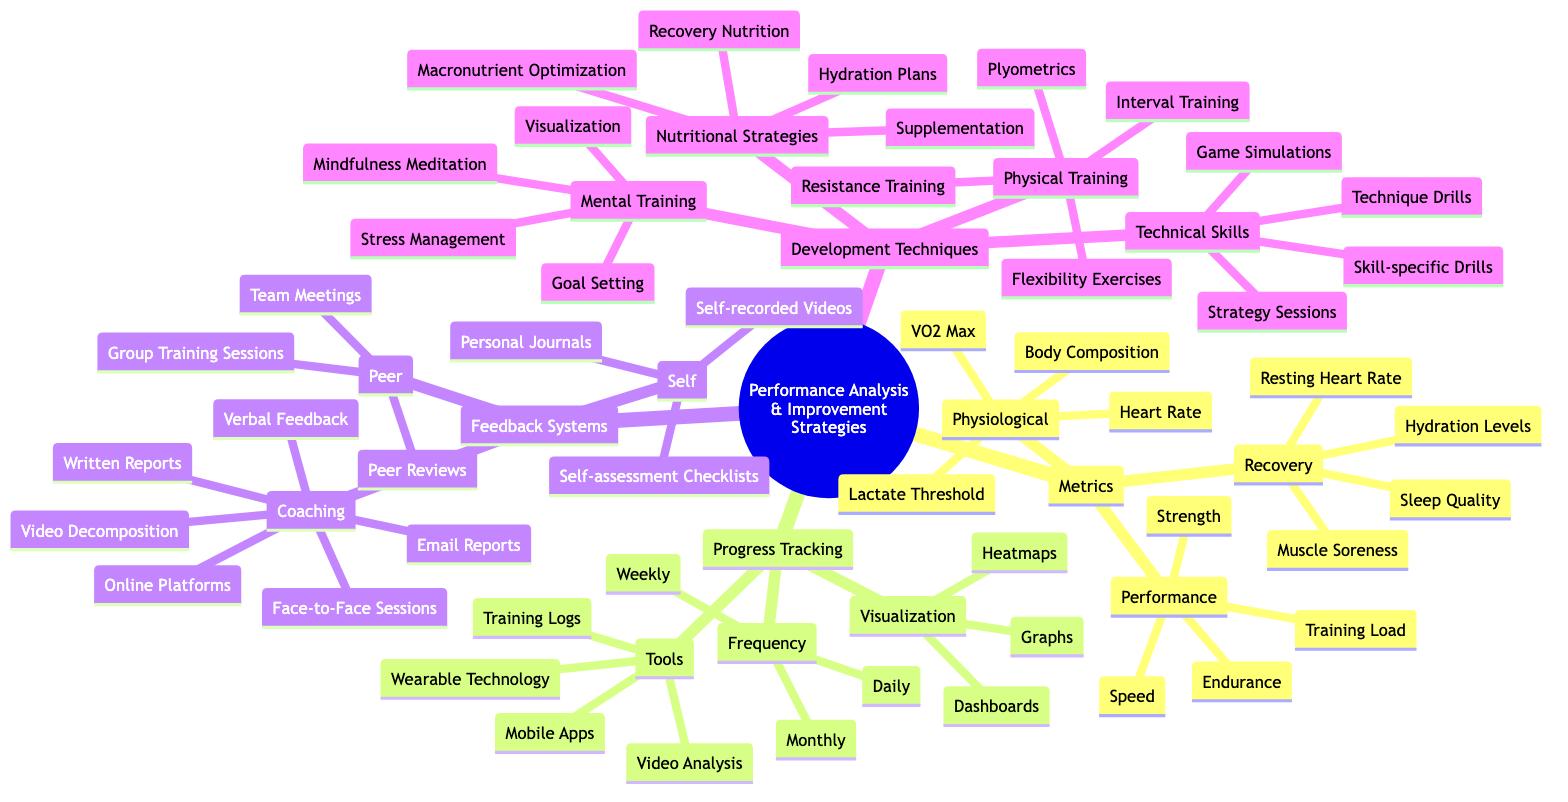What are the categories of metrics in the performance analysis? The diagram lists three main categories of metrics: Physiological, Performance, and Recovery, indicating the different aspects of performance assessment.
Answer: Physiological, Performance, Recovery How many types of feedback channels are listed under coaching? Under the Coaching section, there are three feedback channels: Face-to-Face Sessions, Online Platforms, and Email Reports, which represent the methods of providing feedback.
Answer: 3 What training technique is mentioned under Mental Training? The Mental Training section includes Visualization, which is one of the techniques aimed at developing an athlete's mental skills for improved performance.
Answer: Visualization Which tool is used for progress tracking? The diagram shows Mobile Apps as one of the tools listed under Progress Tracking, which are often used by athletes to monitor their training and performance.
Answer: Mobile Apps How many techniques are listed under Physical Training? The Physical Training section contains four techniques: Interval Training, Resistance Training, Plyometrics, and Flexibility Exercises, indicating various methods of physical conditioning.
Answer: 4 What type of visualization is mentioned in progress tracking? Graphs are specified as one of the types of visualization tools used in progress tracking, allowing athletes to see their performance trends over time.
Answer: Graphs Which nutritional strategy focuses on hydration? The Nutritional Strategies section mentions Hydration Plans, which emphasize the importance of maintaining proper hydration for athletic performance.
Answer: Hydration Plans What is a method for self-assessment listed in the feedback systems? Self-assessment Checklists are identified in the Self section of Feedback Systems, providing athletes a way to evaluate their own performance.
Answer: Self-assessment Checklists What type of drills are included in the Technical Skills category? The Technical Skills section lists Technique Drills, which are specific exercises aimed at refining the skills required in sporting activities.
Answer: Technique Drills 